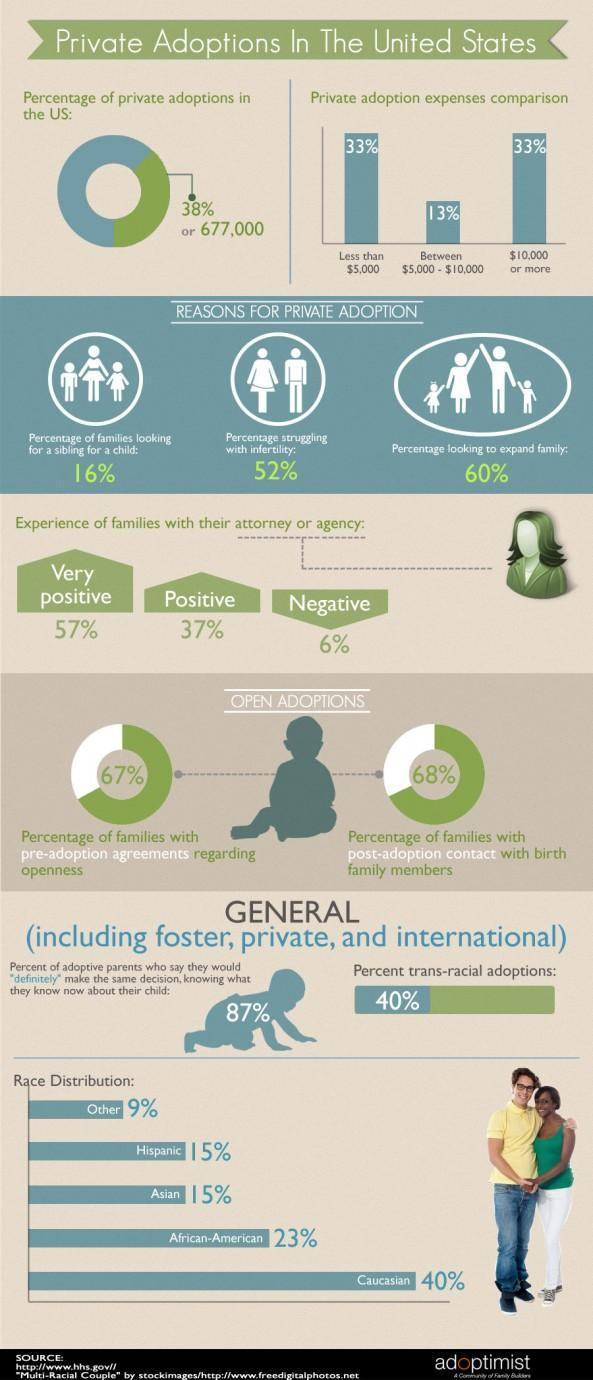What percentage of couples are not looking to expand their family in U.S.?
Answer the question with a short phrase. 40% What is the percentage of private adoptions in the U.S.? 38% What percentage of couples are struggling with infertility in U.S.? 52% 